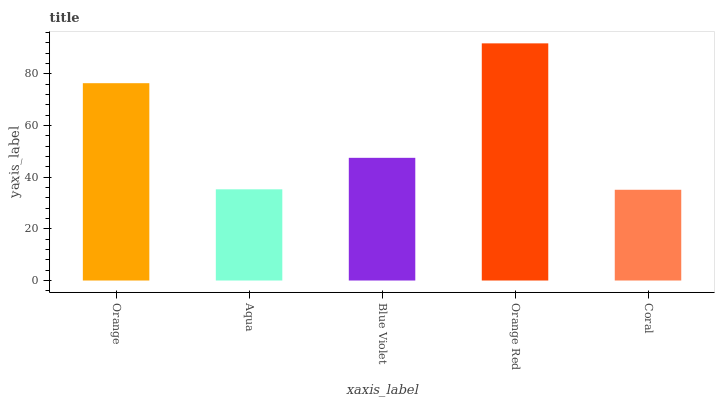Is Coral the minimum?
Answer yes or no. Yes. Is Orange Red the maximum?
Answer yes or no. Yes. Is Aqua the minimum?
Answer yes or no. No. Is Aqua the maximum?
Answer yes or no. No. Is Orange greater than Aqua?
Answer yes or no. Yes. Is Aqua less than Orange?
Answer yes or no. Yes. Is Aqua greater than Orange?
Answer yes or no. No. Is Orange less than Aqua?
Answer yes or no. No. Is Blue Violet the high median?
Answer yes or no. Yes. Is Blue Violet the low median?
Answer yes or no. Yes. Is Aqua the high median?
Answer yes or no. No. Is Coral the low median?
Answer yes or no. No. 